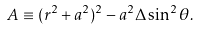Convert formula to latex. <formula><loc_0><loc_0><loc_500><loc_500>A \equiv ( r ^ { 2 } + a ^ { 2 } ) ^ { 2 } - a ^ { 2 } \Delta \sin ^ { 2 } \theta .</formula> 